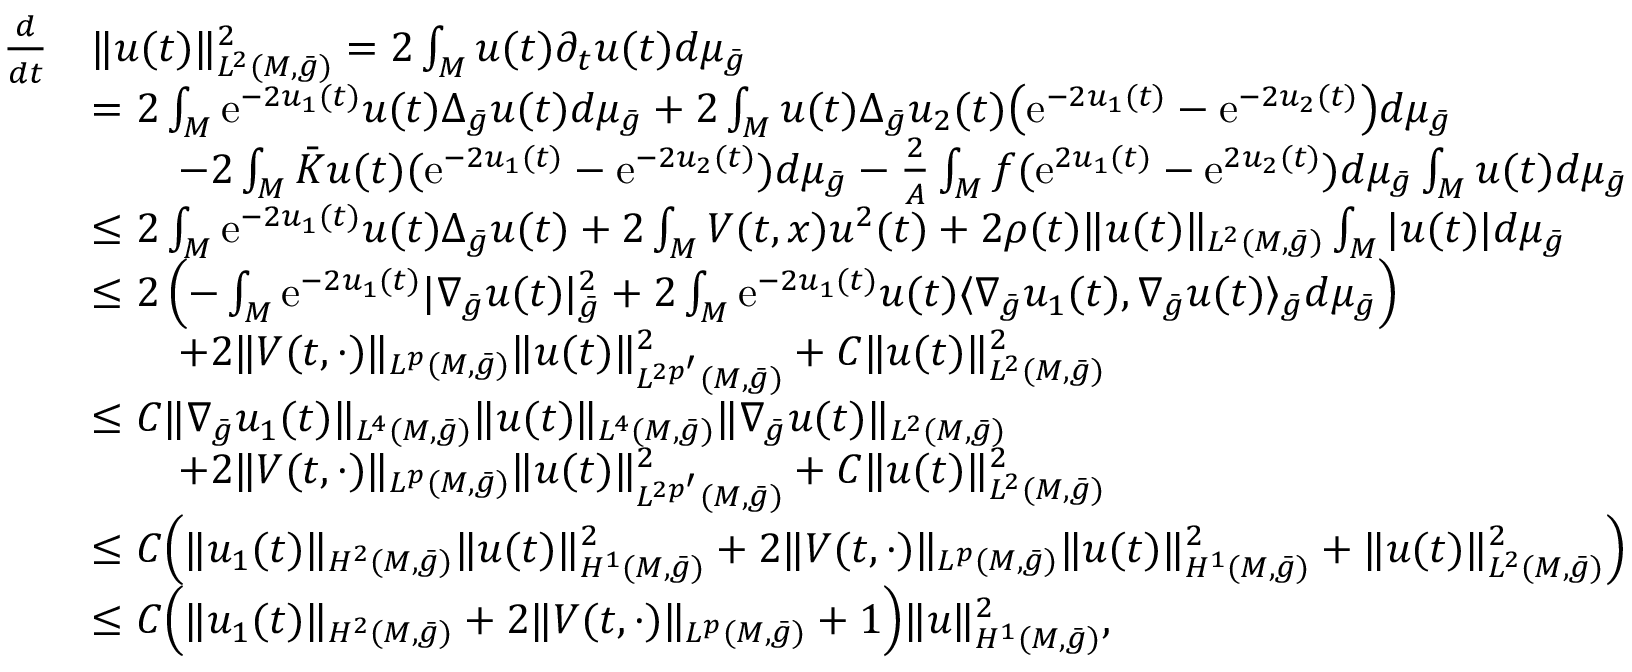Convert formula to latex. <formula><loc_0><loc_0><loc_500><loc_500>\begin{array} { r l } { \frac { d } { d t } } & { \| u ( t ) \| _ { L ^ { 2 } ( M , \bar { g } ) } ^ { 2 } = 2 \int _ { M } u ( t ) \partial _ { t } u ( t ) d \mu _ { \bar { g } } } \\ & { = 2 \int _ { M } e ^ { - 2 u _ { 1 } ( t ) } u ( t ) \Delta _ { \bar { g } } u ( t ) d \mu _ { \bar { g } } + 2 \int _ { M } u ( t ) \Delta _ { \bar { g } } u _ { 2 } ( t ) \left ( e ^ { - 2 u _ { 1 } ( t ) } - e ^ { - 2 u _ { 2 } ( t ) } \right ) d \mu _ { \bar { g } } } \\ & { \quad - 2 \int _ { M } \bar { K } u ( t ) ( e ^ { - 2 u _ { 1 } ( t ) } - e ^ { - 2 u _ { 2 } ( t ) } ) d \mu _ { \bar { g } } - \frac { 2 } { A } \int _ { M } f ( e ^ { 2 u _ { 1 } ( t ) } - e ^ { 2 u _ { 2 } ( t ) } ) d \mu _ { \bar { g } } \int _ { M } u ( t ) d \mu _ { \bar { g } } } \\ & { \leq 2 \int _ { M } e ^ { - 2 u _ { 1 } ( t ) } u ( t ) \Delta _ { \bar { g } } u ( t ) + 2 \int _ { M } V ( t , x ) u ^ { 2 } ( t ) + 2 \rho ( t ) \| u ( t ) \| _ { L ^ { 2 } ( M , \bar { g } ) } \int _ { M } | u ( t ) | d \mu _ { \bar { g } } } \\ & { \leq 2 \left ( - \int _ { M } e ^ { - 2 u _ { 1 } ( t ) } | \nabla _ { \bar { g } } u ( t ) | _ { \bar { g } } ^ { 2 } + 2 \int _ { M } e ^ { - 2 u _ { 1 } ( t ) } u ( t ) \langle \nabla _ { \bar { g } } u _ { 1 } ( t ) , \nabla _ { \bar { g } } u ( t ) \rangle _ { \bar { g } } d \mu _ { \bar { g } } \right ) } \\ & { \quad + 2 \| V ( t , \cdot ) \| _ { L ^ { p } ( M , \bar { g } ) } \| u ( t ) \| _ { L ^ { 2 p ^ { \prime } } ( M , \bar { g } ) } ^ { 2 } + C \| u ( t ) \| _ { L ^ { 2 } ( M , \bar { g } ) } ^ { 2 } } \\ & { \leq C \| \nabla _ { \bar { g } } u _ { 1 } ( t ) \| _ { L ^ { 4 } ( M , \bar { g } ) } \| u ( t ) \| _ { L ^ { 4 } ( M , \bar { g } ) } \| \nabla _ { \bar { g } } u ( t ) \| _ { L ^ { 2 } ( M , \bar { g } ) } } \\ & { \quad + 2 \| V ( t , \cdot ) \| _ { L ^ { p } ( M , \bar { g } ) } \| u ( t ) \| _ { L ^ { 2 p ^ { \prime } } ( M , \bar { g } ) } ^ { 2 } + C \| u ( t ) \| _ { L ^ { 2 } ( M , \bar { g } ) } ^ { 2 } } \\ & { \leq C \left ( \| u _ { 1 } ( t ) \| _ { H ^ { 2 } ( M , \bar { g } ) } \| u ( t ) \| _ { H ^ { 1 } ( M , \bar { g } ) } ^ { 2 } + 2 \| V ( t , \cdot ) \| _ { L ^ { p } ( M , \bar { g } ) } \| u ( t ) \| _ { H ^ { 1 } ( M , \bar { g } ) } ^ { 2 } + \| u ( t ) \| _ { L ^ { 2 } ( M , \bar { g } ) } ^ { 2 } \right ) } \\ & { \leq C \left ( \| u _ { 1 } ( t ) \| _ { H ^ { 2 } ( M , \bar { g } ) } + 2 \| V ( t , \cdot ) \| _ { L ^ { p } ( M , \bar { g } ) } + 1 \right ) \| u \| _ { H ^ { 1 } ( M , \bar { g } ) } ^ { 2 } , } \end{array}</formula> 